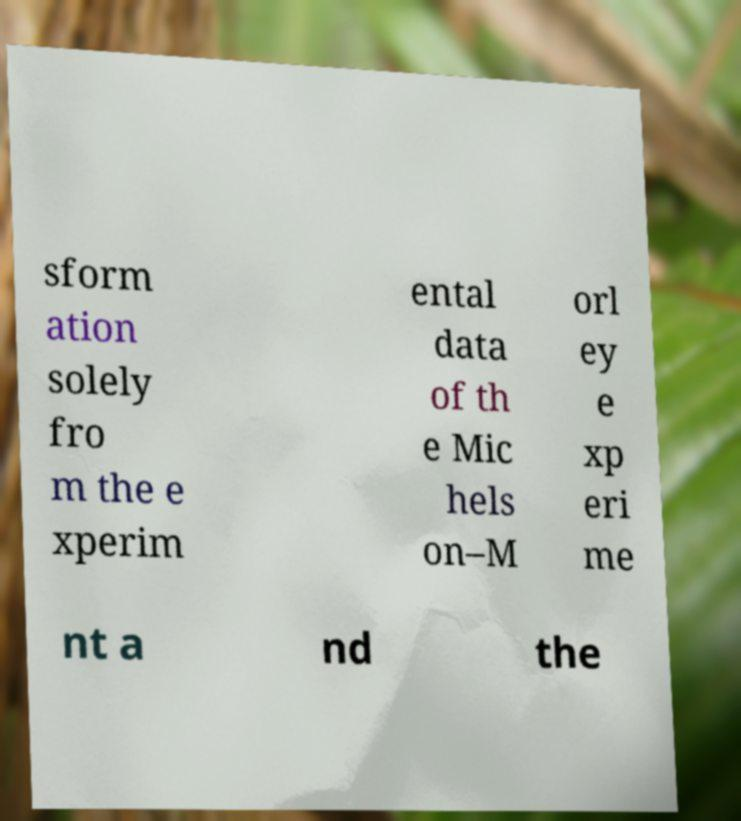For documentation purposes, I need the text within this image transcribed. Could you provide that? sform ation solely fro m the e xperim ental data of th e Mic hels on–M orl ey e xp eri me nt a nd the 